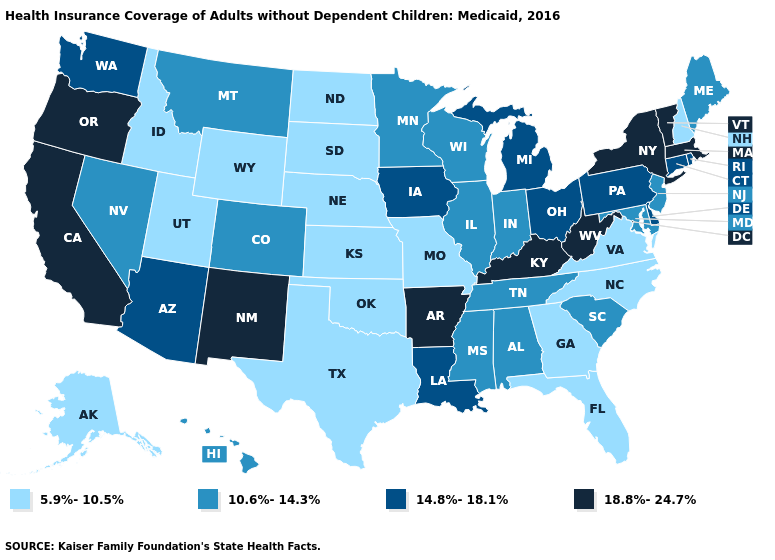Name the states that have a value in the range 10.6%-14.3%?
Write a very short answer. Alabama, Colorado, Hawaii, Illinois, Indiana, Maine, Maryland, Minnesota, Mississippi, Montana, Nevada, New Jersey, South Carolina, Tennessee, Wisconsin. What is the value of Georgia?
Concise answer only. 5.9%-10.5%. What is the highest value in the Northeast ?
Keep it brief. 18.8%-24.7%. What is the value of Nevada?
Keep it brief. 10.6%-14.3%. What is the lowest value in the Northeast?
Write a very short answer. 5.9%-10.5%. What is the highest value in states that border Connecticut?
Write a very short answer. 18.8%-24.7%. Name the states that have a value in the range 18.8%-24.7%?
Give a very brief answer. Arkansas, California, Kentucky, Massachusetts, New Mexico, New York, Oregon, Vermont, West Virginia. What is the value of Connecticut?
Quick response, please. 14.8%-18.1%. Does Maine have the highest value in the Northeast?
Quick response, please. No. Among the states that border Alabama , which have the lowest value?
Answer briefly. Florida, Georgia. Does Connecticut have a lower value than Arizona?
Quick response, please. No. Does Maine have the highest value in the Northeast?
Keep it brief. No. What is the value of Oklahoma?
Short answer required. 5.9%-10.5%. Does the first symbol in the legend represent the smallest category?
Short answer required. Yes. Among the states that border Delaware , does Maryland have the highest value?
Write a very short answer. No. 